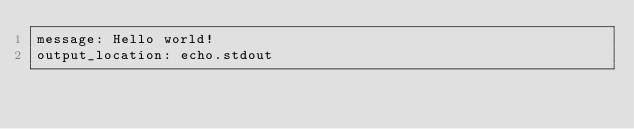Convert code to text. <code><loc_0><loc_0><loc_500><loc_500><_YAML_>message: Hello world!
output_location: echo.stdout

</code> 